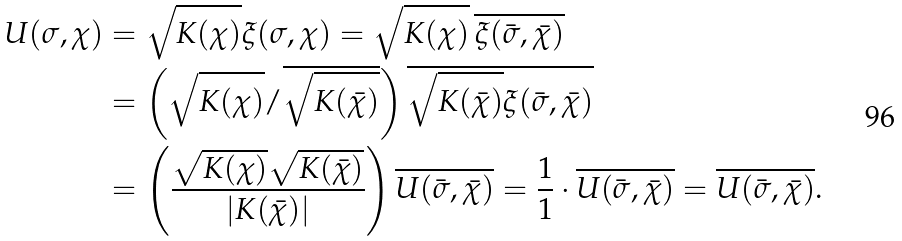Convert formula to latex. <formula><loc_0><loc_0><loc_500><loc_500>U ( \sigma , \chi ) & = \sqrt { K ( \chi ) } \xi ( \sigma , \chi ) = \sqrt { K ( \chi ) } \, \overline { \xi ( \bar { \sigma } , \bar { \chi } ) } \\ & = \left ( \sqrt { K ( \chi ) } / \overline { \sqrt { K ( \bar { \chi } ) } } \right ) \overline { \sqrt { K ( \bar { \chi } ) } \xi ( \bar { \sigma } , \bar { \chi } ) } \\ & = \left ( \frac { \sqrt { K ( \chi ) } \sqrt { K ( \bar { \chi } ) } } { | K ( \bar { \chi } ) | } \right ) \overline { U ( \bar { \sigma } , \bar { \chi } ) } = \frac { 1 } { 1 } \cdot \overline { U ( \bar { \sigma } , \bar { \chi } ) } = \overline { U ( \bar { \sigma } , \bar { \chi } ) } .</formula> 